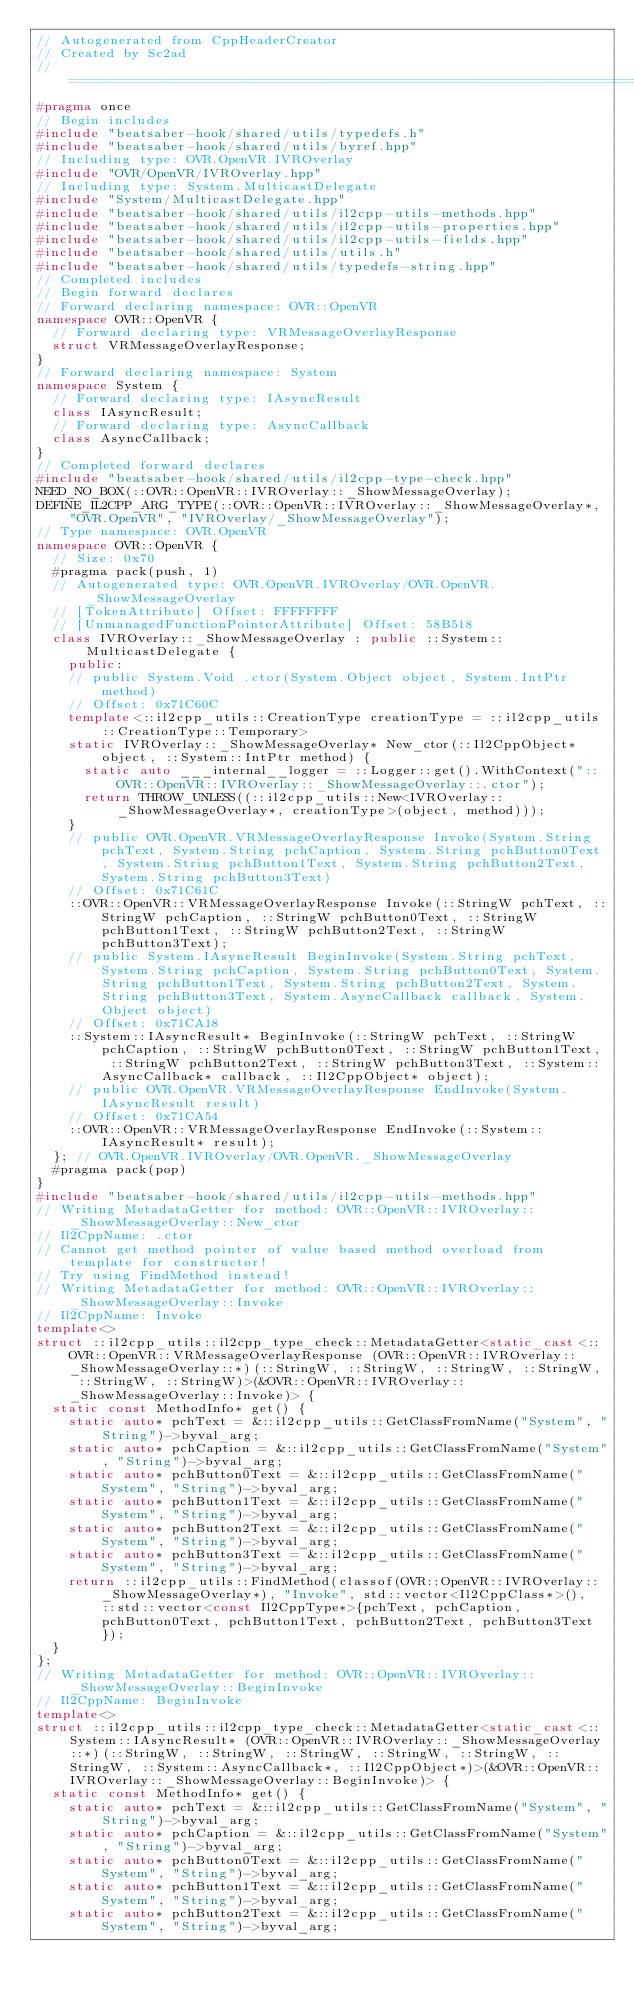<code> <loc_0><loc_0><loc_500><loc_500><_C++_>// Autogenerated from CppHeaderCreator
// Created by Sc2ad
// =========================================================================
#pragma once
// Begin includes
#include "beatsaber-hook/shared/utils/typedefs.h"
#include "beatsaber-hook/shared/utils/byref.hpp"
// Including type: OVR.OpenVR.IVROverlay
#include "OVR/OpenVR/IVROverlay.hpp"
// Including type: System.MulticastDelegate
#include "System/MulticastDelegate.hpp"
#include "beatsaber-hook/shared/utils/il2cpp-utils-methods.hpp"
#include "beatsaber-hook/shared/utils/il2cpp-utils-properties.hpp"
#include "beatsaber-hook/shared/utils/il2cpp-utils-fields.hpp"
#include "beatsaber-hook/shared/utils/utils.h"
#include "beatsaber-hook/shared/utils/typedefs-string.hpp"
// Completed includes
// Begin forward declares
// Forward declaring namespace: OVR::OpenVR
namespace OVR::OpenVR {
  // Forward declaring type: VRMessageOverlayResponse
  struct VRMessageOverlayResponse;
}
// Forward declaring namespace: System
namespace System {
  // Forward declaring type: IAsyncResult
  class IAsyncResult;
  // Forward declaring type: AsyncCallback
  class AsyncCallback;
}
// Completed forward declares
#include "beatsaber-hook/shared/utils/il2cpp-type-check.hpp"
NEED_NO_BOX(::OVR::OpenVR::IVROverlay::_ShowMessageOverlay);
DEFINE_IL2CPP_ARG_TYPE(::OVR::OpenVR::IVROverlay::_ShowMessageOverlay*, "OVR.OpenVR", "IVROverlay/_ShowMessageOverlay");
// Type namespace: OVR.OpenVR
namespace OVR::OpenVR {
  // Size: 0x70
  #pragma pack(push, 1)
  // Autogenerated type: OVR.OpenVR.IVROverlay/OVR.OpenVR._ShowMessageOverlay
  // [TokenAttribute] Offset: FFFFFFFF
  // [UnmanagedFunctionPointerAttribute] Offset: 58B518
  class IVROverlay::_ShowMessageOverlay : public ::System::MulticastDelegate {
    public:
    // public System.Void .ctor(System.Object object, System.IntPtr method)
    // Offset: 0x71C60C
    template<::il2cpp_utils::CreationType creationType = ::il2cpp_utils::CreationType::Temporary>
    static IVROverlay::_ShowMessageOverlay* New_ctor(::Il2CppObject* object, ::System::IntPtr method) {
      static auto ___internal__logger = ::Logger::get().WithContext("::OVR::OpenVR::IVROverlay::_ShowMessageOverlay::.ctor");
      return THROW_UNLESS((::il2cpp_utils::New<IVROverlay::_ShowMessageOverlay*, creationType>(object, method)));
    }
    // public OVR.OpenVR.VRMessageOverlayResponse Invoke(System.String pchText, System.String pchCaption, System.String pchButton0Text, System.String pchButton1Text, System.String pchButton2Text, System.String pchButton3Text)
    // Offset: 0x71C61C
    ::OVR::OpenVR::VRMessageOverlayResponse Invoke(::StringW pchText, ::StringW pchCaption, ::StringW pchButton0Text, ::StringW pchButton1Text, ::StringW pchButton2Text, ::StringW pchButton3Text);
    // public System.IAsyncResult BeginInvoke(System.String pchText, System.String pchCaption, System.String pchButton0Text, System.String pchButton1Text, System.String pchButton2Text, System.String pchButton3Text, System.AsyncCallback callback, System.Object object)
    // Offset: 0x71CA18
    ::System::IAsyncResult* BeginInvoke(::StringW pchText, ::StringW pchCaption, ::StringW pchButton0Text, ::StringW pchButton1Text, ::StringW pchButton2Text, ::StringW pchButton3Text, ::System::AsyncCallback* callback, ::Il2CppObject* object);
    // public OVR.OpenVR.VRMessageOverlayResponse EndInvoke(System.IAsyncResult result)
    // Offset: 0x71CA54
    ::OVR::OpenVR::VRMessageOverlayResponse EndInvoke(::System::IAsyncResult* result);
  }; // OVR.OpenVR.IVROverlay/OVR.OpenVR._ShowMessageOverlay
  #pragma pack(pop)
}
#include "beatsaber-hook/shared/utils/il2cpp-utils-methods.hpp"
// Writing MetadataGetter for method: OVR::OpenVR::IVROverlay::_ShowMessageOverlay::New_ctor
// Il2CppName: .ctor
// Cannot get method pointer of value based method overload from template for constructor!
// Try using FindMethod instead!
// Writing MetadataGetter for method: OVR::OpenVR::IVROverlay::_ShowMessageOverlay::Invoke
// Il2CppName: Invoke
template<>
struct ::il2cpp_utils::il2cpp_type_check::MetadataGetter<static_cast<::OVR::OpenVR::VRMessageOverlayResponse (OVR::OpenVR::IVROverlay::_ShowMessageOverlay::*)(::StringW, ::StringW, ::StringW, ::StringW, ::StringW, ::StringW)>(&OVR::OpenVR::IVROverlay::_ShowMessageOverlay::Invoke)> {
  static const MethodInfo* get() {
    static auto* pchText = &::il2cpp_utils::GetClassFromName("System", "String")->byval_arg;
    static auto* pchCaption = &::il2cpp_utils::GetClassFromName("System", "String")->byval_arg;
    static auto* pchButton0Text = &::il2cpp_utils::GetClassFromName("System", "String")->byval_arg;
    static auto* pchButton1Text = &::il2cpp_utils::GetClassFromName("System", "String")->byval_arg;
    static auto* pchButton2Text = &::il2cpp_utils::GetClassFromName("System", "String")->byval_arg;
    static auto* pchButton3Text = &::il2cpp_utils::GetClassFromName("System", "String")->byval_arg;
    return ::il2cpp_utils::FindMethod(classof(OVR::OpenVR::IVROverlay::_ShowMessageOverlay*), "Invoke", std::vector<Il2CppClass*>(), ::std::vector<const Il2CppType*>{pchText, pchCaption, pchButton0Text, pchButton1Text, pchButton2Text, pchButton3Text});
  }
};
// Writing MetadataGetter for method: OVR::OpenVR::IVROverlay::_ShowMessageOverlay::BeginInvoke
// Il2CppName: BeginInvoke
template<>
struct ::il2cpp_utils::il2cpp_type_check::MetadataGetter<static_cast<::System::IAsyncResult* (OVR::OpenVR::IVROverlay::_ShowMessageOverlay::*)(::StringW, ::StringW, ::StringW, ::StringW, ::StringW, ::StringW, ::System::AsyncCallback*, ::Il2CppObject*)>(&OVR::OpenVR::IVROverlay::_ShowMessageOverlay::BeginInvoke)> {
  static const MethodInfo* get() {
    static auto* pchText = &::il2cpp_utils::GetClassFromName("System", "String")->byval_arg;
    static auto* pchCaption = &::il2cpp_utils::GetClassFromName("System", "String")->byval_arg;
    static auto* pchButton0Text = &::il2cpp_utils::GetClassFromName("System", "String")->byval_arg;
    static auto* pchButton1Text = &::il2cpp_utils::GetClassFromName("System", "String")->byval_arg;
    static auto* pchButton2Text = &::il2cpp_utils::GetClassFromName("System", "String")->byval_arg;</code> 